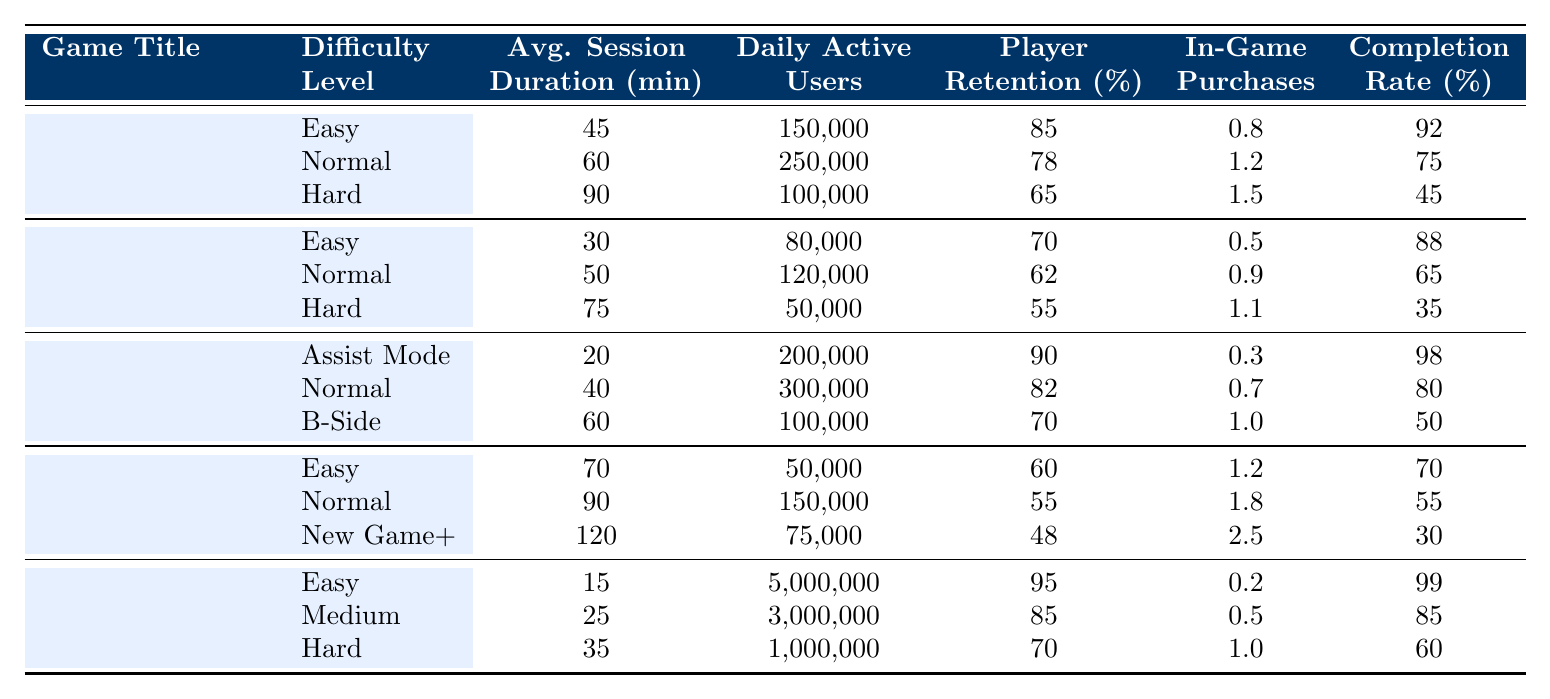What is the average session duration for "Dark Souls III" on the Hard difficulty level? From the table, the average session duration for "Dark Souls III" on Hard is listed as 120 minutes.
Answer: 120 minutes What is the player retention rate for "Celeste" in Assist Mode? According to the table, the player retention rate for "Celeste" in Assist Mode is 90%.
Answer: 90% Which game has the highest daily active users on the Easy difficulty level? "Candy Crush Saga" has the highest daily active users at 5,000,000 when set to Easy difficulty.
Answer: 5,000,000 What is the difference in average session duration between "The Witness" on Easy and Hard difficulties? The average session duration for "The Witness" Easy is 30 minutes and Hard is 75 minutes, so the difference is 75 - 30 = 45 minutes.
Answer: 45 minutes Which game difficulty level has the highest completion rate? Examining the completion rates, "Celeste" in Assist Mode has the highest completion rate at 98%.
Answer: 98% What is the average in-game purchases per user across all difficulty levels of "Portal 2"? For "Portal 2", the in-game purchases per user are 0.8 (Easy), 1.2 (Normal), and 1.5 (Hard). Summing these gives 0.8 + 1.2 + 1.5 = 3.5, and then dividing by 3 gives an average of 3.5 / 3 = 1.17.
Answer: 1.17 True or False: The player retention rate for "Dark Souls III" on Easy is higher than that of "The Witness" on Hard. The player retention rate for "Dark Souls III" Easy is 60%, whereas "The Witness" Hard is 55%. Therefore, the statement is true.
Answer: True What is the total number of daily active users across all difficulty levels for "Candy Crush Saga"? For "Candy Crush Saga", the daily active users are 5,000,000 (Easy), 3,000,000 (Medium), and 1,000,000 (Hard). Adding these gives 5,000,000 + 3,000,000 + 1,000,000 = 9,000,000 users.
Answer: 9,000,000 What trend can you observe in the completion rates of "Dark Souls III" across its different difficulty levels? The completion rates for "Dark Souls III" are 70% (Easy), 55% (Normal), and 30% (New Game+), showing a declining trend as the difficulty increases.
Answer: Declining trend Is the average session duration in "Normal" difficulty for "Celeste" higher than for "The Witness"? "Celeste" has an average session duration of 40 minutes, and "The Witness" has 50 minutes in Normal difficulty. Thus, "The Witness" has a higher average session duration.
Answer: No 